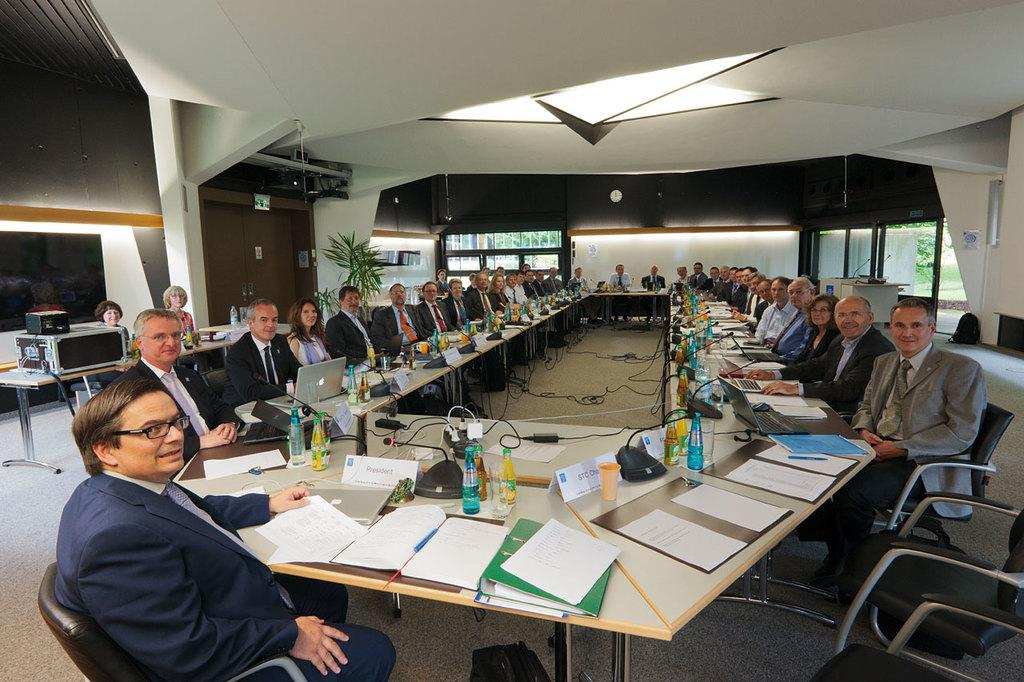What type of wall is present in the image? There is a color wall in the image. What are the people in the image doing? The people are sitting on chairs in the image. What furniture is visible in the image? There is a table in the image. What items can be seen on the table? There are books, files, papers, bottles, mics, and glasses on the table. What type of engine is visible on the table in the image? There is no engine present on the table in the image. What type of meat is being served on the table in the image? There is no meat present on the table in the image. 